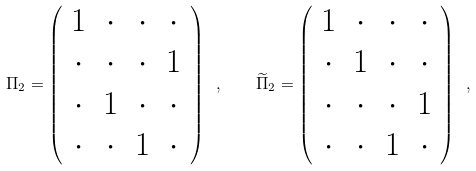Convert formula to latex. <formula><loc_0><loc_0><loc_500><loc_500>\Pi _ { 2 } = \left ( \begin{array} { c c c c } 1 & \cdot & \cdot & \cdot \\ \cdot & \cdot & \cdot & 1 \\ \cdot & 1 & \cdot & \cdot \\ \cdot & \cdot & 1 & \cdot \end{array} \right ) \ , \quad \widetilde { \Pi } _ { 2 } = \left ( \begin{array} { c c c c } 1 & \cdot & \cdot & \cdot \\ \cdot & 1 & \cdot & \cdot \\ \cdot & \cdot & \cdot & 1 \\ \cdot & \cdot & 1 & \cdot \end{array} \right ) \ ,</formula> 